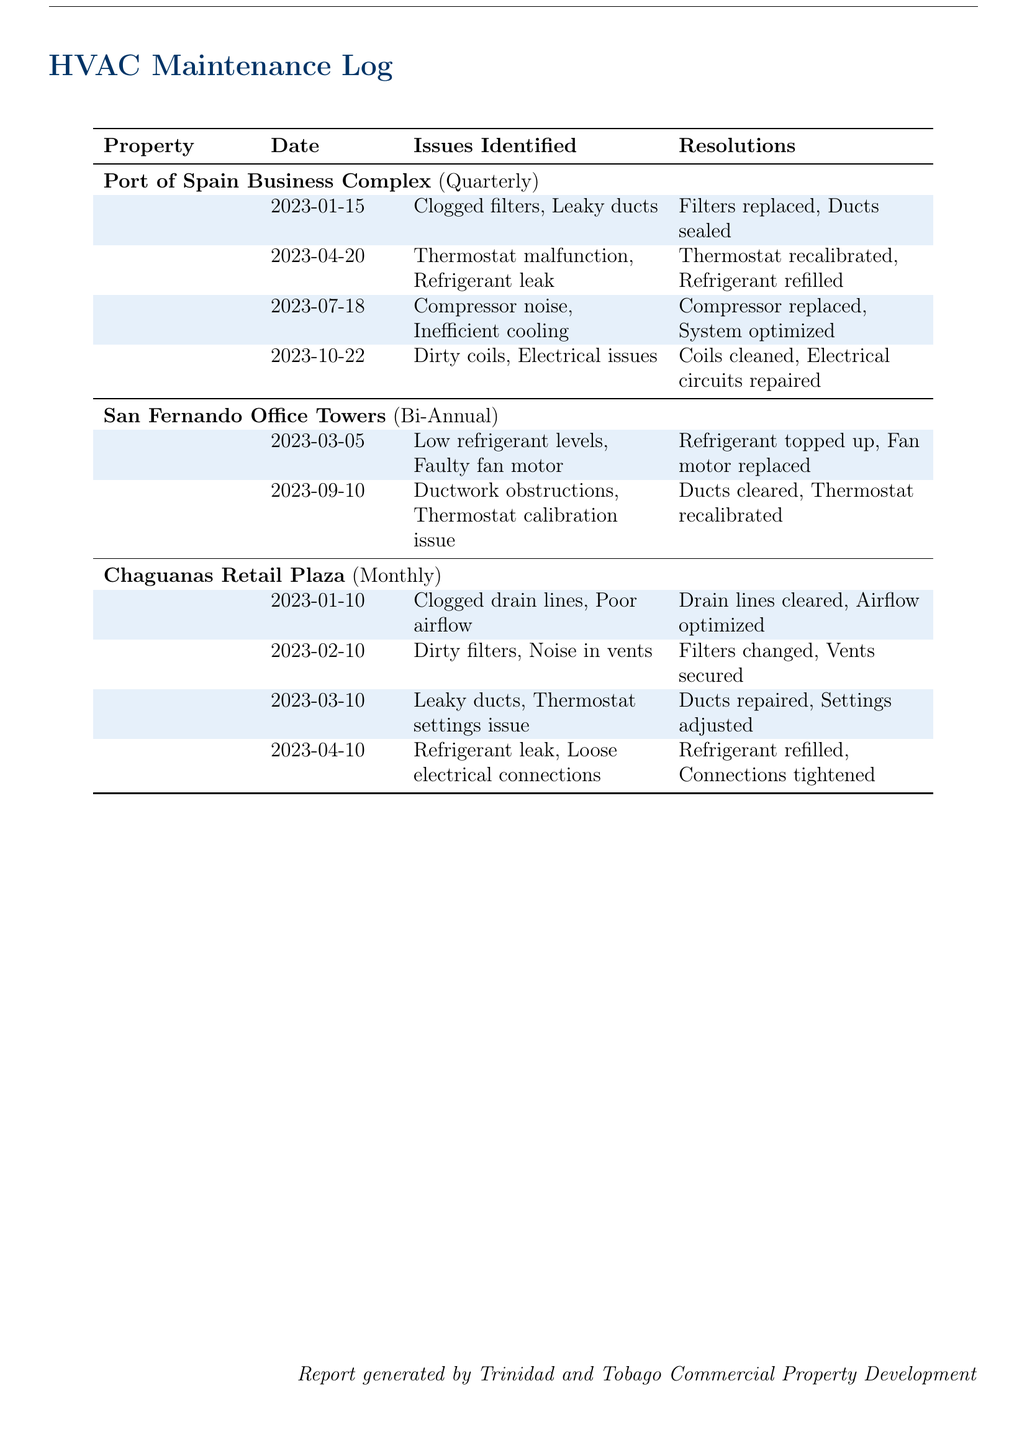What is the name of the first property listed? The first property mentioned in the log is the Port of Spain Business Complex.
Answer: Port of Spain Business Complex When was the last maintenance performed for San Fernando Office Towers? The last maintenance for San Fernando Office Towers was on September 10, 2023.
Answer: September 10, 2023 How many times was maintenance performed for Chaguanas Retail Plaza in 2023? Maintenance for Chaguanas Retail Plaza was performed monthly, resulting in a total of four times by April.
Answer: 4 times What issue was resolved during the maintenance on April 10, 2023, for Chaguanas Retail Plaza? On April 10, 2023, the issue resolved was a refrigerant leak.
Answer: Refrigerant leak Which property had a compressor replaced on July 18, 2023? The Port of Spain Business Complex had a compressor replaced.
Answer: Port of Spain Business Complex What resolution was made for the faulty fan motor issue in San Fernando Office Towers? The resolution for the faulty fan motor was that it was replaced.
Answer: Fan motor replaced How many issues were identified during maintenance in the first quarter for the Port of Spain Business Complex? Four issues were identified during the first quarter's maintenance visits.
Answer: 4 issues What color is used for the rows in the maintenance log? The color used for the alternating rows in the log is light blue.
Answer: Light blue 